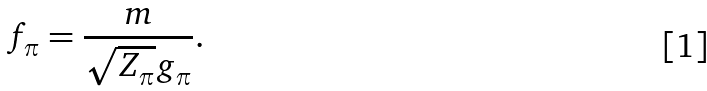Convert formula to latex. <formula><loc_0><loc_0><loc_500><loc_500>f _ { \pi } = \frac { m } { \sqrt { Z _ { \pi } } g _ { \pi } } .</formula> 